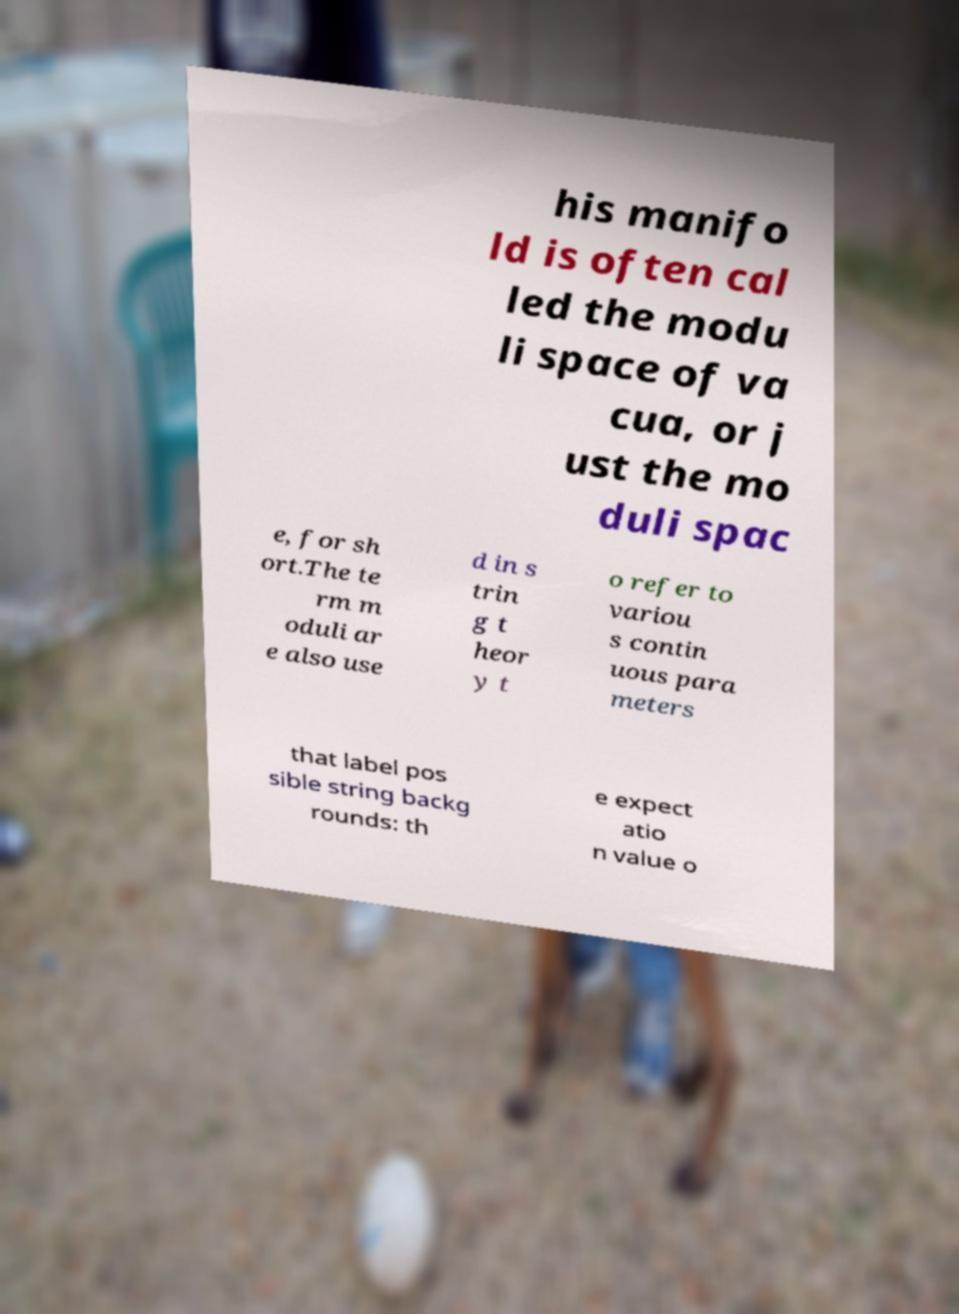Could you assist in decoding the text presented in this image and type it out clearly? his manifo ld is often cal led the modu li space of va cua, or j ust the mo duli spac e, for sh ort.The te rm m oduli ar e also use d in s trin g t heor y t o refer to variou s contin uous para meters that label pos sible string backg rounds: th e expect atio n value o 